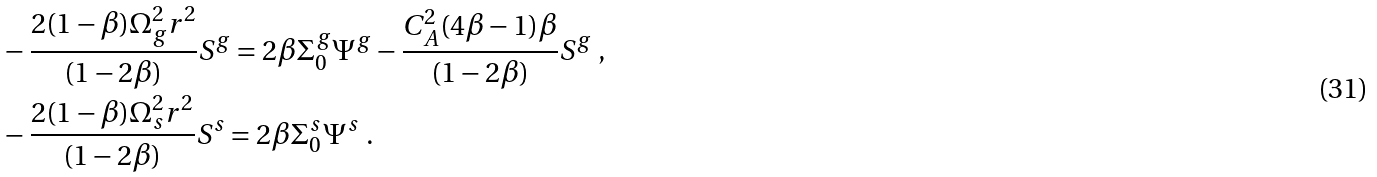Convert formula to latex. <formula><loc_0><loc_0><loc_500><loc_500>& - \frac { 2 ( 1 - \beta ) \Omega _ { g } ^ { 2 } r ^ { 2 } } { ( 1 - 2 \beta ) } S ^ { g } = 2 \beta \Sigma _ { 0 } ^ { g } \Psi ^ { g } - \frac { C _ { A } ^ { 2 } ( 4 \beta - 1 ) \beta } { ( 1 - 2 \beta ) } S ^ { g } \ , \\ & - \frac { 2 ( 1 - \beta ) \Omega _ { s } ^ { 2 } r ^ { 2 } } { ( 1 - 2 \beta ) } S ^ { s } = 2 \beta \Sigma _ { 0 } ^ { s } \Psi ^ { s } \ .</formula> 